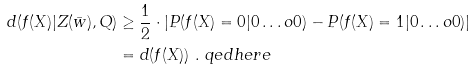Convert formula to latex. <formula><loc_0><loc_0><loc_500><loc_500>d ( f ( X ) | Z ( \bar { w } ) , Q ) & \geq \frac { 1 } { 2 } \cdot \left | P ( { f ( { X } ) = 0 | { 0 \dots o 0 } } ) - P ( { f ( { X } ) = 1 | { 0 \dots o 0 } } ) \right | \\ & = d ( f ( { X } ) ) \ . \ q e d h e r e</formula> 